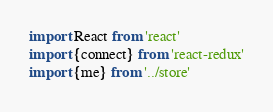Convert code to text. <code><loc_0><loc_0><loc_500><loc_500><_JavaScript_>import React from 'react'
import {connect} from 'react-redux'
import {me} from '../store'</code> 